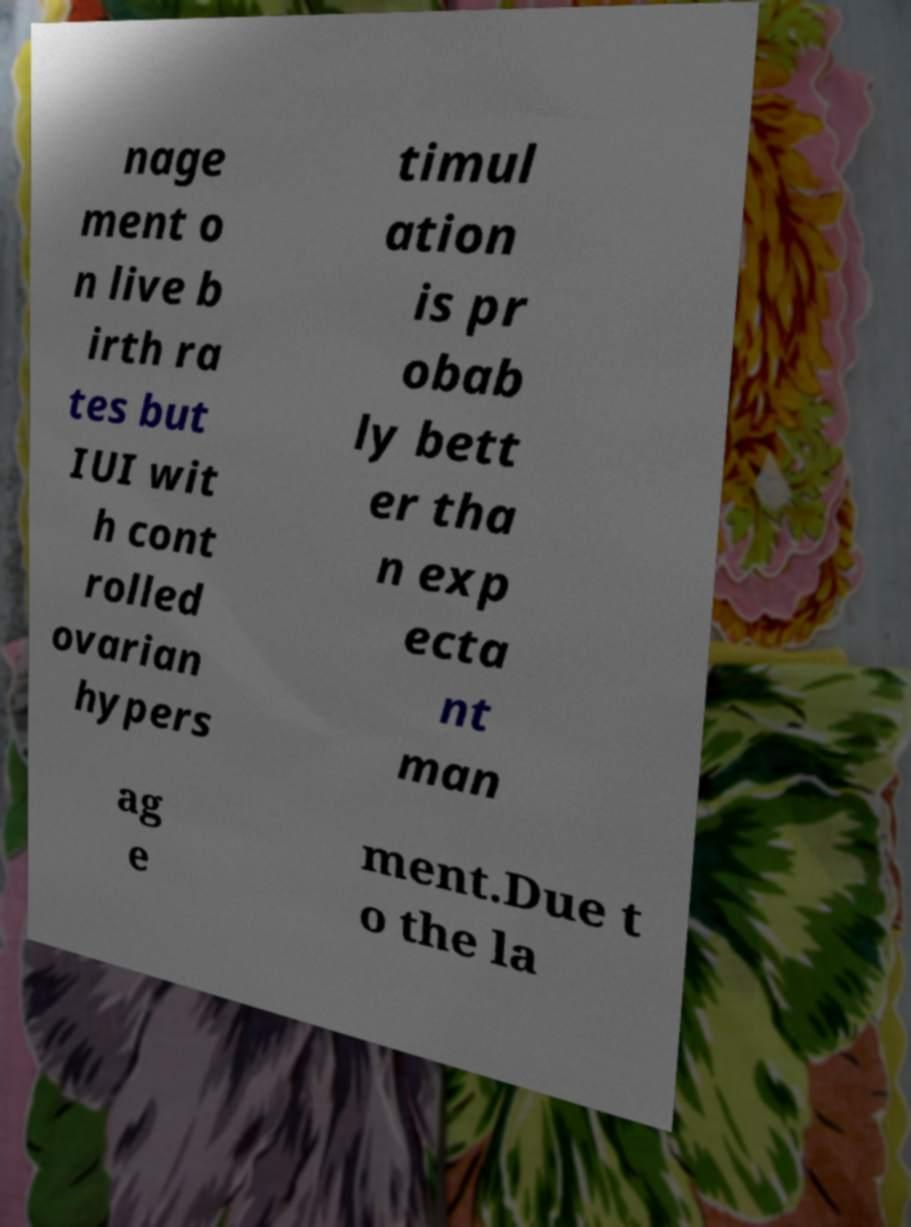Please identify and transcribe the text found in this image. nage ment o n live b irth ra tes but IUI wit h cont rolled ovarian hypers timul ation is pr obab ly bett er tha n exp ecta nt man ag e ment.Due t o the la 